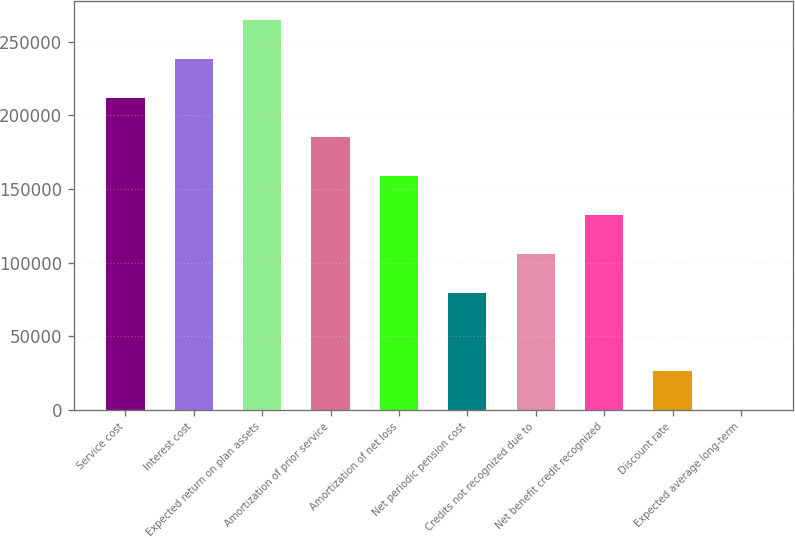Convert chart to OTSL. <chart><loc_0><loc_0><loc_500><loc_500><bar_chart><fcel>Service cost<fcel>Interest cost<fcel>Expected return on plan assets<fcel>Amortization of prior service<fcel>Amortization of net loss<fcel>Net periodic pension cost<fcel>Credits not recognized due to<fcel>Net benefit credit recognized<fcel>Discount rate<fcel>Expected average long-term<nl><fcel>211866<fcel>238348<fcel>264831<fcel>185383<fcel>158900<fcel>79452.1<fcel>105935<fcel>132418<fcel>26486.7<fcel>4<nl></chart> 